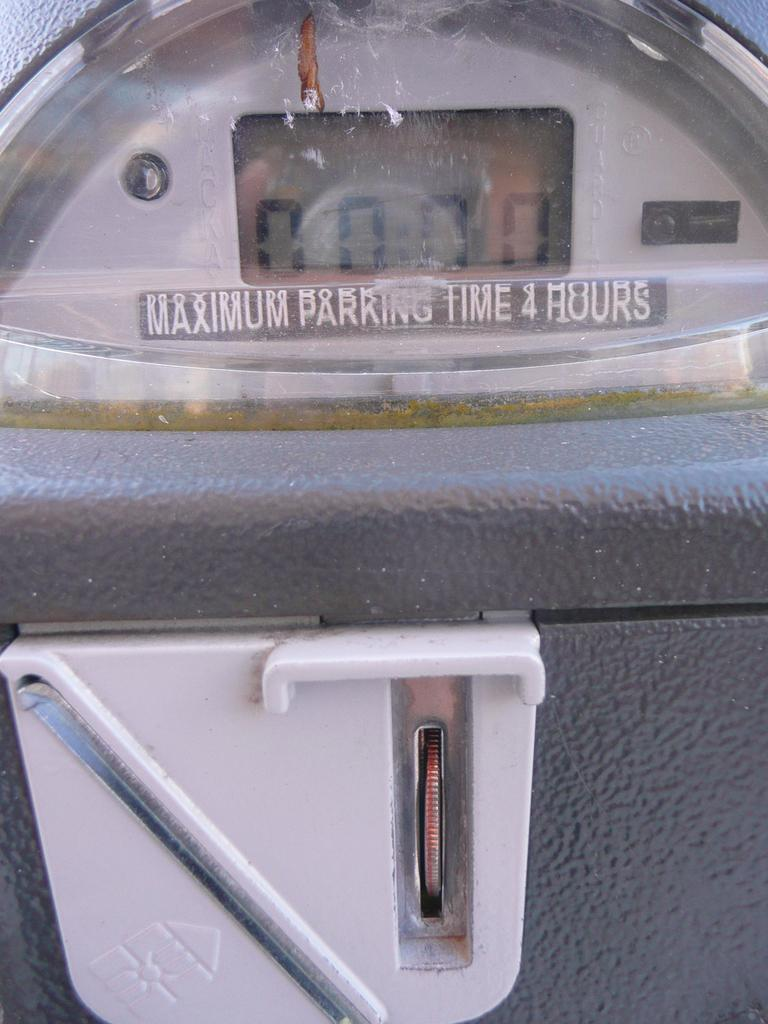<image>
Give a short and clear explanation of the subsequent image. A parking meter says that the maximum parking time is 4 hours. 